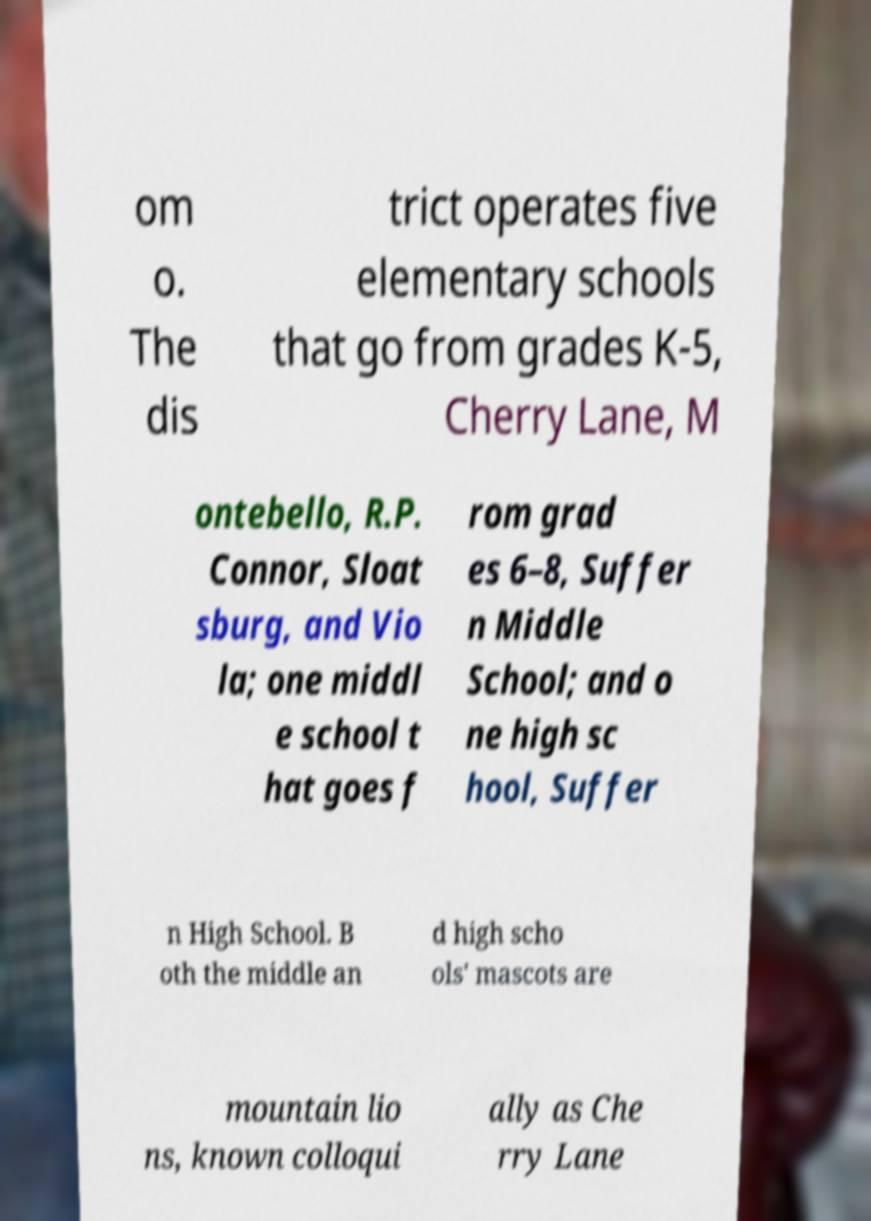Please read and relay the text visible in this image. What does it say? om o. The dis trict operates five elementary schools that go from grades K-5, Cherry Lane, M ontebello, R.P. Connor, Sloat sburg, and Vio la; one middl e school t hat goes f rom grad es 6–8, Suffer n Middle School; and o ne high sc hool, Suffer n High School. B oth the middle an d high scho ols' mascots are mountain lio ns, known colloqui ally as Che rry Lane 